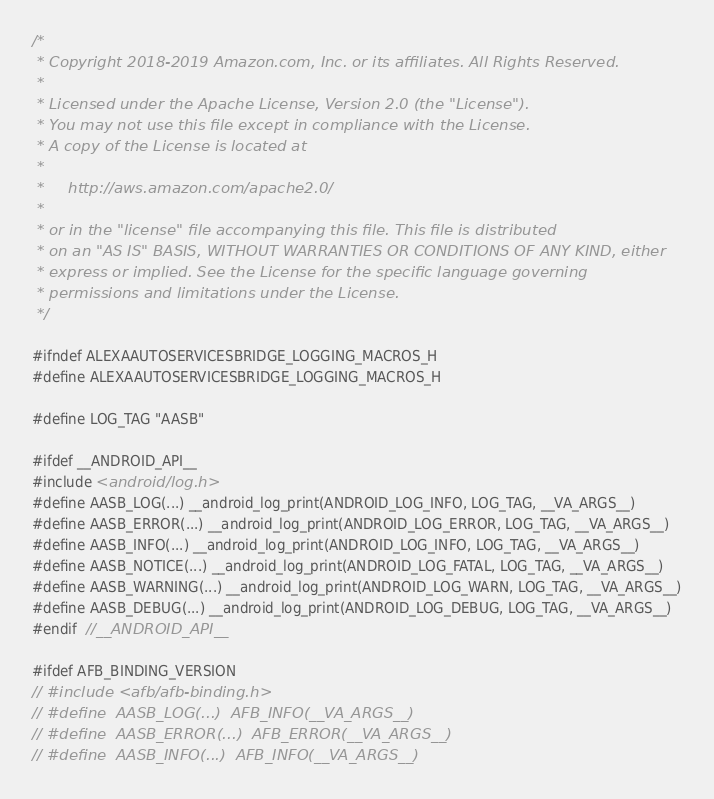Convert code to text. <code><loc_0><loc_0><loc_500><loc_500><_C_>/*
 * Copyright 2018-2019 Amazon.com, Inc. or its affiliates. All Rights Reserved.
 *
 * Licensed under the Apache License, Version 2.0 (the "License").
 * You may not use this file except in compliance with the License.
 * A copy of the License is located at
 *
 *     http://aws.amazon.com/apache2.0/
 *
 * or in the "license" file accompanying this file. This file is distributed
 * on an "AS IS" BASIS, WITHOUT WARRANTIES OR CONDITIONS OF ANY KIND, either
 * express or implied. See the License for the specific language governing
 * permissions and limitations under the License.
 */

#ifndef ALEXAAUTOSERVICESBRIDGE_LOGGING_MACROS_H
#define ALEXAAUTOSERVICESBRIDGE_LOGGING_MACROS_H

#define LOG_TAG "AASB"

#ifdef __ANDROID_API__
#include <android/log.h>
#define AASB_LOG(...) __android_log_print(ANDROID_LOG_INFO, LOG_TAG, __VA_ARGS__)
#define AASB_ERROR(...) __android_log_print(ANDROID_LOG_ERROR, LOG_TAG, __VA_ARGS__)
#define AASB_INFO(...) __android_log_print(ANDROID_LOG_INFO, LOG_TAG, __VA_ARGS__)
#define AASB_NOTICE(...) __android_log_print(ANDROID_LOG_FATAL, LOG_TAG, __VA_ARGS__)
#define AASB_WARNING(...) __android_log_print(ANDROID_LOG_WARN, LOG_TAG, __VA_ARGS__)
#define AASB_DEBUG(...) __android_log_print(ANDROID_LOG_DEBUG, LOG_TAG, __VA_ARGS__)
#endif  //__ANDROID_API__

#ifdef AFB_BINDING_VERSION
// #include <afb/afb-binding.h>
// #define  AASB_LOG(...)  AFB_INFO(__VA_ARGS__)
// #define  AASB_ERROR(...)  AFB_ERROR(__VA_ARGS__)
// #define  AASB_INFO(...)  AFB_INFO(__VA_ARGS__)</code> 